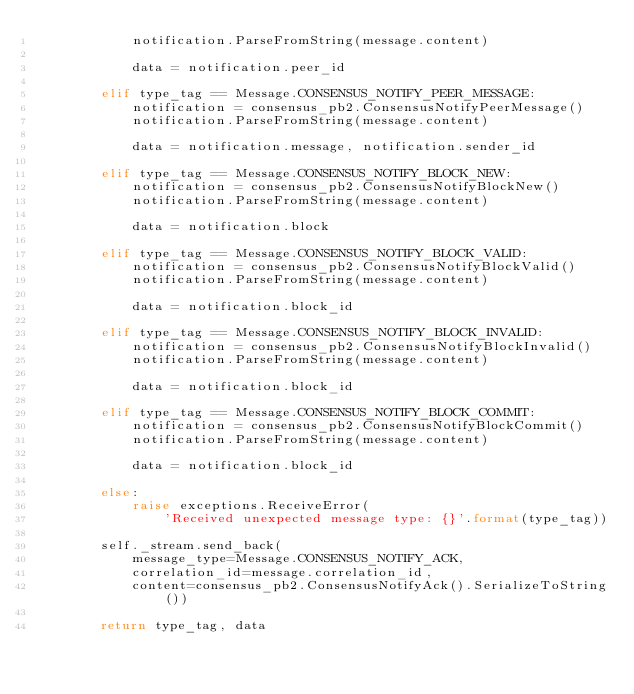<code> <loc_0><loc_0><loc_500><loc_500><_Python_>            notification.ParseFromString(message.content)

            data = notification.peer_id

        elif type_tag == Message.CONSENSUS_NOTIFY_PEER_MESSAGE:
            notification = consensus_pb2.ConsensusNotifyPeerMessage()
            notification.ParseFromString(message.content)

            data = notification.message, notification.sender_id

        elif type_tag == Message.CONSENSUS_NOTIFY_BLOCK_NEW:
            notification = consensus_pb2.ConsensusNotifyBlockNew()
            notification.ParseFromString(message.content)

            data = notification.block

        elif type_tag == Message.CONSENSUS_NOTIFY_BLOCK_VALID:
            notification = consensus_pb2.ConsensusNotifyBlockValid()
            notification.ParseFromString(message.content)

            data = notification.block_id

        elif type_tag == Message.CONSENSUS_NOTIFY_BLOCK_INVALID:
            notification = consensus_pb2.ConsensusNotifyBlockInvalid()
            notification.ParseFromString(message.content)

            data = notification.block_id

        elif type_tag == Message.CONSENSUS_NOTIFY_BLOCK_COMMIT:
            notification = consensus_pb2.ConsensusNotifyBlockCommit()
            notification.ParseFromString(message.content)

            data = notification.block_id

        else:
            raise exceptions.ReceiveError(
                'Received unexpected message type: {}'.format(type_tag))

        self._stream.send_back(
            message_type=Message.CONSENSUS_NOTIFY_ACK,
            correlation_id=message.correlation_id,
            content=consensus_pb2.ConsensusNotifyAck().SerializeToString())

        return type_tag, data
</code> 